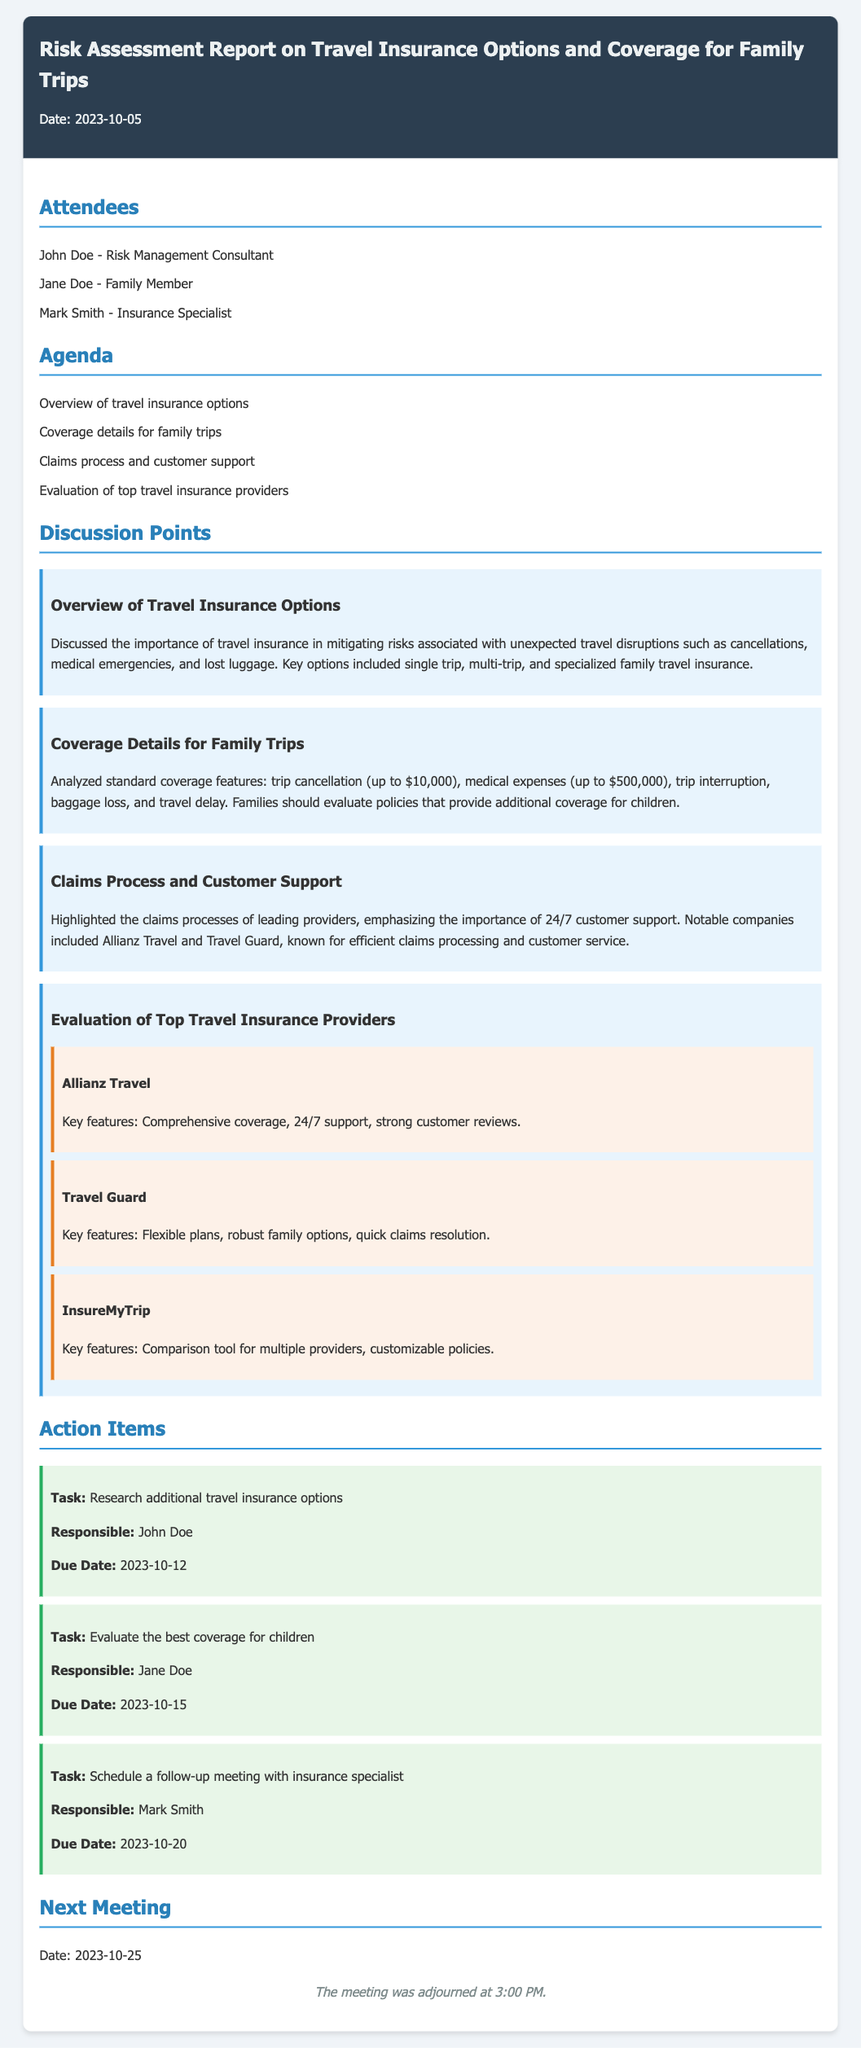What is the date of the meeting? The date of the meeting is provided at the top of the document under the header section.
Answer: 2023-10-05 Who is responsible for researching additional travel insurance options? The action item section lists the tasks and the individuals responsible for each task.
Answer: John Doe What are the maximum trip cancellation costs mentioned? The coverage details for family trips includes information about trip cancellation limits, which are specified in the discussion points.
Answer: up to $10,000 Which company is highlighted for its 24/7 support? The claims process discussion points out notable companies and their support features.
Answer: Allianz Travel What is the due date for evaluating the best coverage for children? The action items specify the tasks along with their due dates.
Answer: 2023-10-15 How many attendees were listed in the meeting? The attendees section provides a list of individuals present in the meeting.
Answer: 3 What type of insurance is emphasized for families in the overview? The overview of travel insurance options discusses types of insurance relevant to families.
Answer: specialized family travel insurance What was the general tone of the document regarding travel insurance? The document discusses the importance of travel insurance in the face of disruptions.
Answer: Importance of travel insurance 